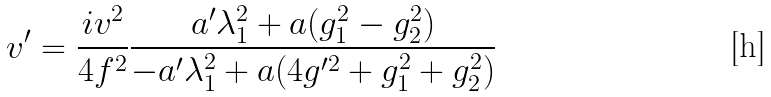<formula> <loc_0><loc_0><loc_500><loc_500>v ^ { \prime } = \frac { i v ^ { 2 } } { 4 f ^ { 2 } } \frac { a ^ { \prime } \lambda _ { 1 } ^ { 2 } + a ( g _ { 1 } ^ { 2 } - g _ { 2 } ^ { 2 } ) } { - a ^ { \prime } \lambda _ { 1 } ^ { 2 } + a ( 4 g ^ { \prime 2 } + g _ { 1 } ^ { 2 } + g _ { 2 } ^ { 2 } ) }</formula> 